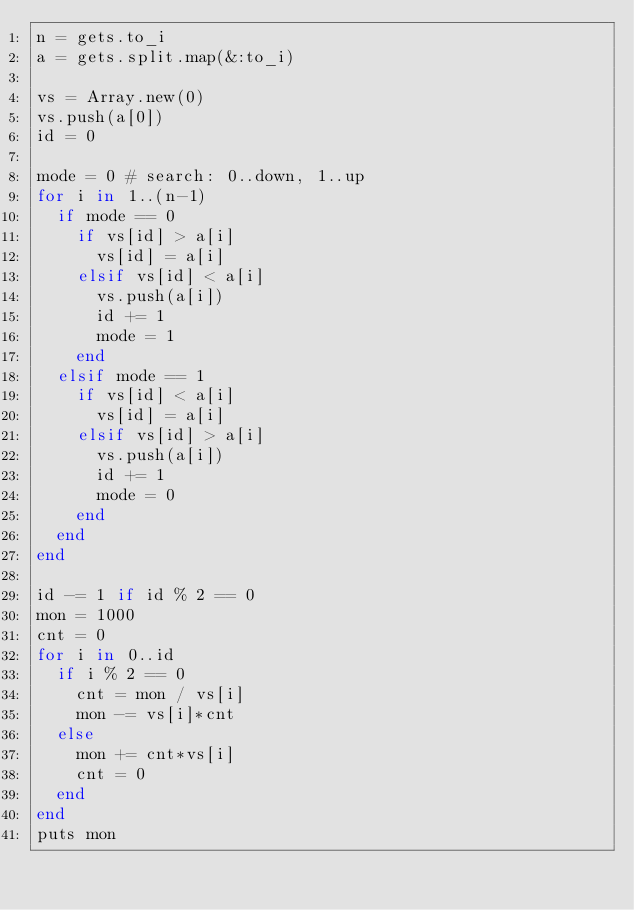<code> <loc_0><loc_0><loc_500><loc_500><_Ruby_>n = gets.to_i
a = gets.split.map(&:to_i)

vs = Array.new(0)
vs.push(a[0])
id = 0

mode = 0 # search: 0..down, 1..up
for i in 1..(n-1)
  if mode == 0
    if vs[id] > a[i]
      vs[id] = a[i]
    elsif vs[id] < a[i]
      vs.push(a[i])
      id += 1
      mode = 1
    end
  elsif mode == 1
    if vs[id] < a[i]
      vs[id] = a[i]
    elsif vs[id] > a[i]
      vs.push(a[i])
      id += 1
      mode = 0
    end
  end
end

id -= 1 if id % 2 == 0
mon = 1000
cnt = 0
for i in 0..id
  if i % 2 == 0
    cnt = mon / vs[i]
    mon -= vs[i]*cnt   
  else
    mon += cnt*vs[i]
    cnt = 0
  end
end
puts mon</code> 